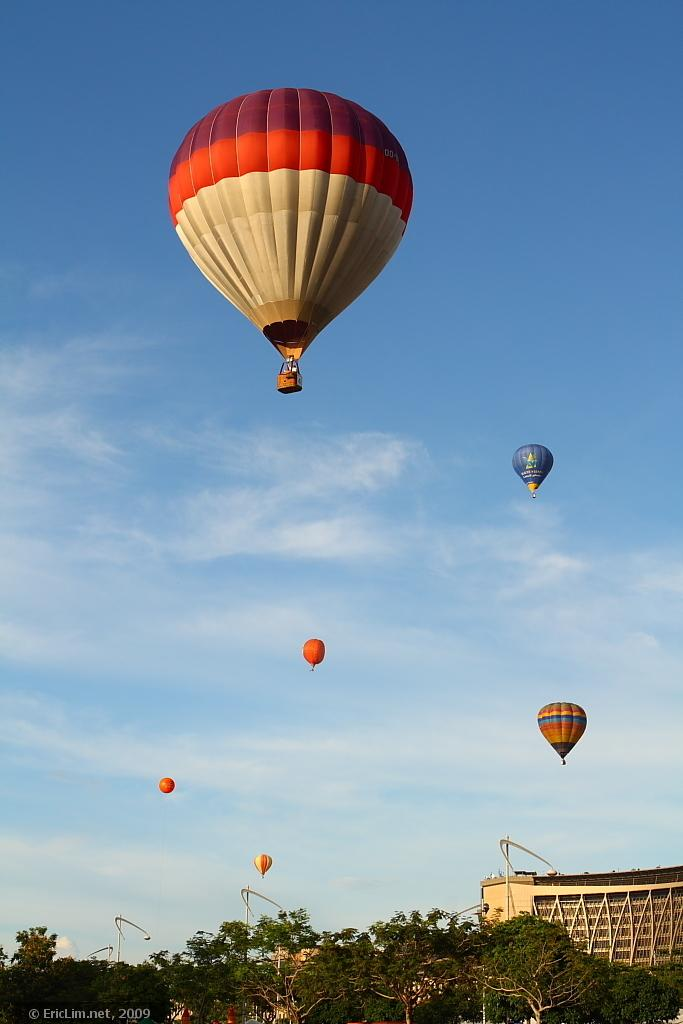What is the main subject of the picture? The main subject of the picture is hot air balloons. What else can be seen in the picture besides the hot air balloons? There are buildings and trees in the picture. Is there any text in the picture? Yes, there is text at the bottom left corner of the picture. How would you describe the sky in the picture? The sky is blue and cloudy. What holiday is being celebrated in the picture? There is no indication of a holiday being celebrated in the picture. What type of straw is used to decorate the buildings in the picture? There is no straw present in the picture; it features hot air balloons, buildings, trees, and text. 